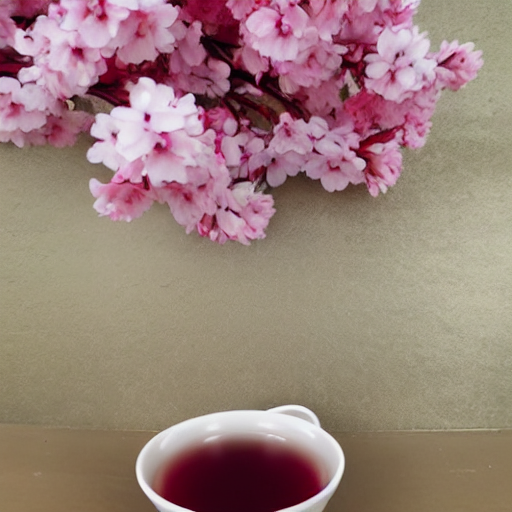Why is the main subject relatively clear? The main subject in this image, which appears to be a cherry blossom branch positioned over a cup, likely seems relatively clear due to the use of a shallow depth of field. This photographic technique keeps the subject in sharp focus while the background is blurred, drawing the viewer's eye to it. 